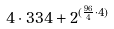Convert formula to latex. <formula><loc_0><loc_0><loc_500><loc_500>4 \cdot 3 3 4 + 2 ^ { ( \frac { 9 6 } { 4 } \cdot 4 ) }</formula> 